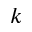<formula> <loc_0><loc_0><loc_500><loc_500>k</formula> 